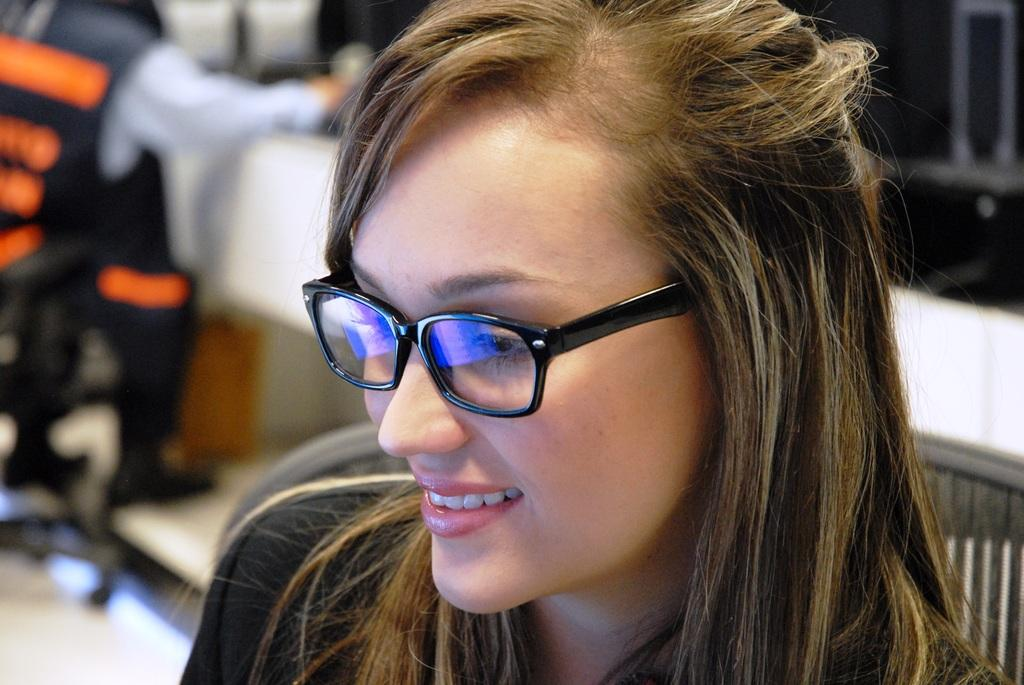Who is the main subject in the image? There is a woman in the image. What can be observed about the woman's appearance? The woman is wearing spectacles. Can you describe the position of the person in the image? There is a person sitting on a chair in the image. What is the person sitting in front of? The person is in front of a table. What type of bird can be seen flying in the image? There is no bird present in the image. Can you tell me the name of the actor who plays the woman in the image? The image is not a scene from a movie or television show, so there is no actor portraying the woman. 